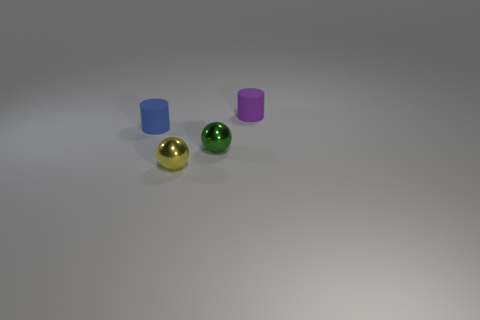Add 1 tiny spheres. How many objects exist? 5 Subtract 0 red cylinders. How many objects are left? 4 Subtract all tiny green shiny cubes. Subtract all small rubber cylinders. How many objects are left? 2 Add 3 blue matte things. How many blue matte things are left? 4 Add 1 small objects. How many small objects exist? 5 